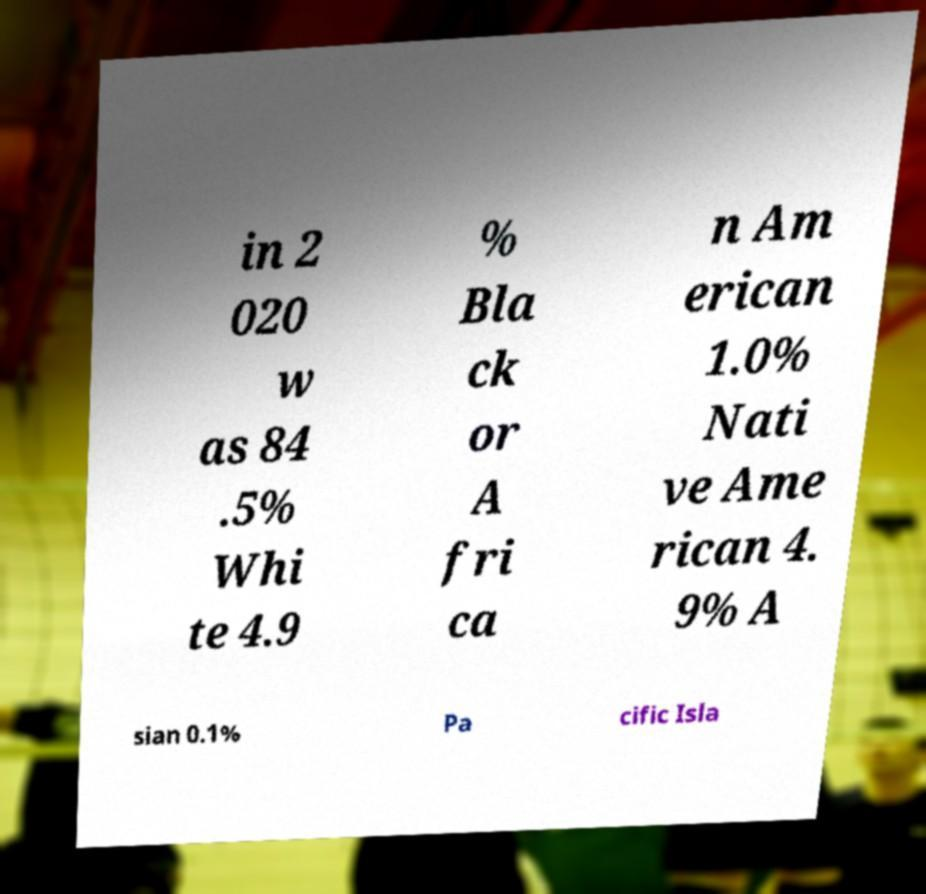What messages or text are displayed in this image? I need them in a readable, typed format. in 2 020 w as 84 .5% Whi te 4.9 % Bla ck or A fri ca n Am erican 1.0% Nati ve Ame rican 4. 9% A sian 0.1% Pa cific Isla 